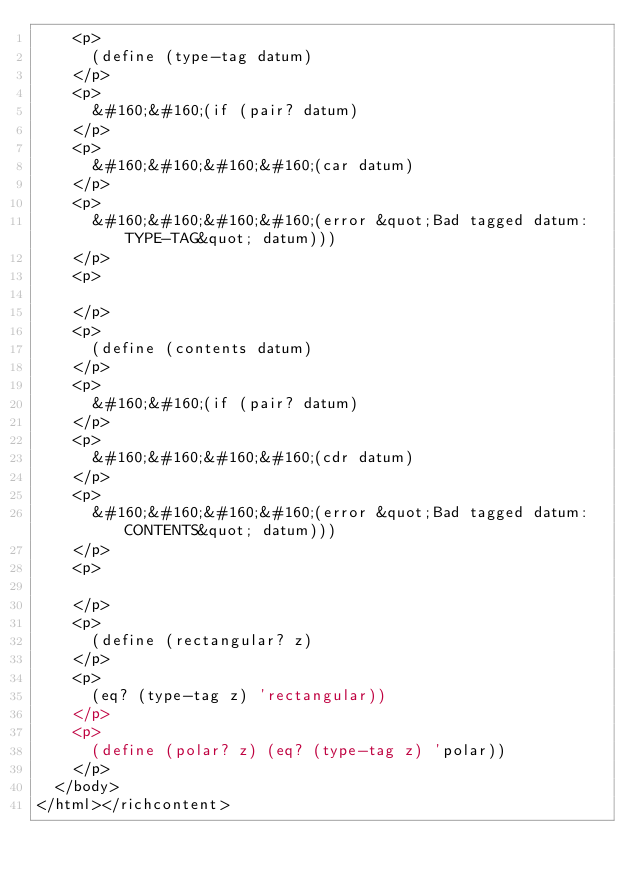<code> <loc_0><loc_0><loc_500><loc_500><_ObjectiveC_>    <p>
      (define (type-tag datum)
    </p>
    <p>
      &#160;&#160;(if (pair? datum)
    </p>
    <p>
      &#160;&#160;&#160;&#160;(car datum)
    </p>
    <p>
      &#160;&#160;&#160;&#160;(error &quot;Bad tagged datum: TYPE-TAG&quot; datum)))
    </p>
    <p>
      
    </p>
    <p>
      (define (contents datum)
    </p>
    <p>
      &#160;&#160;(if (pair? datum)
    </p>
    <p>
      &#160;&#160;&#160;&#160;(cdr datum)
    </p>
    <p>
      &#160;&#160;&#160;&#160;(error &quot;Bad tagged datum: CONTENTS&quot; datum)))
    </p>
    <p>
      
    </p>
    <p>
      (define (rectangular? z)
    </p>
    <p>
      (eq? (type-tag z) 'rectangular))
    </p>
    <p>
      (define (polar? z) (eq? (type-tag z) 'polar))
    </p>
  </body>
</html></richcontent></code> 